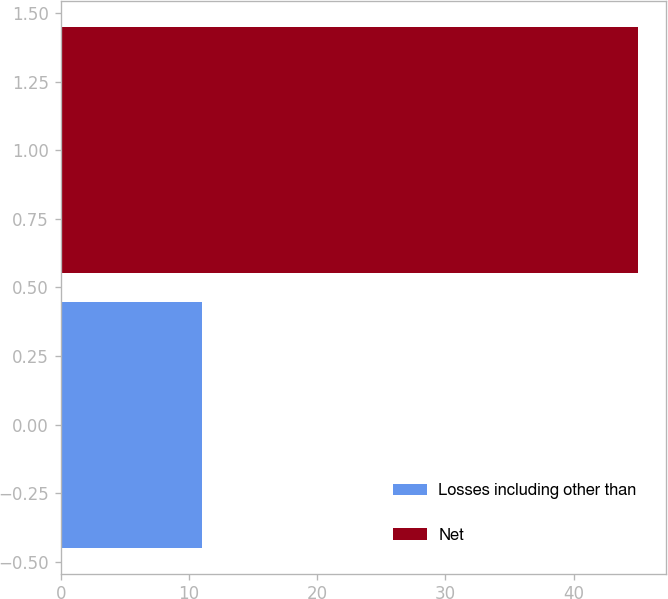Convert chart to OTSL. <chart><loc_0><loc_0><loc_500><loc_500><bar_chart><fcel>Losses including other than<fcel>Net<nl><fcel>11<fcel>45<nl></chart> 